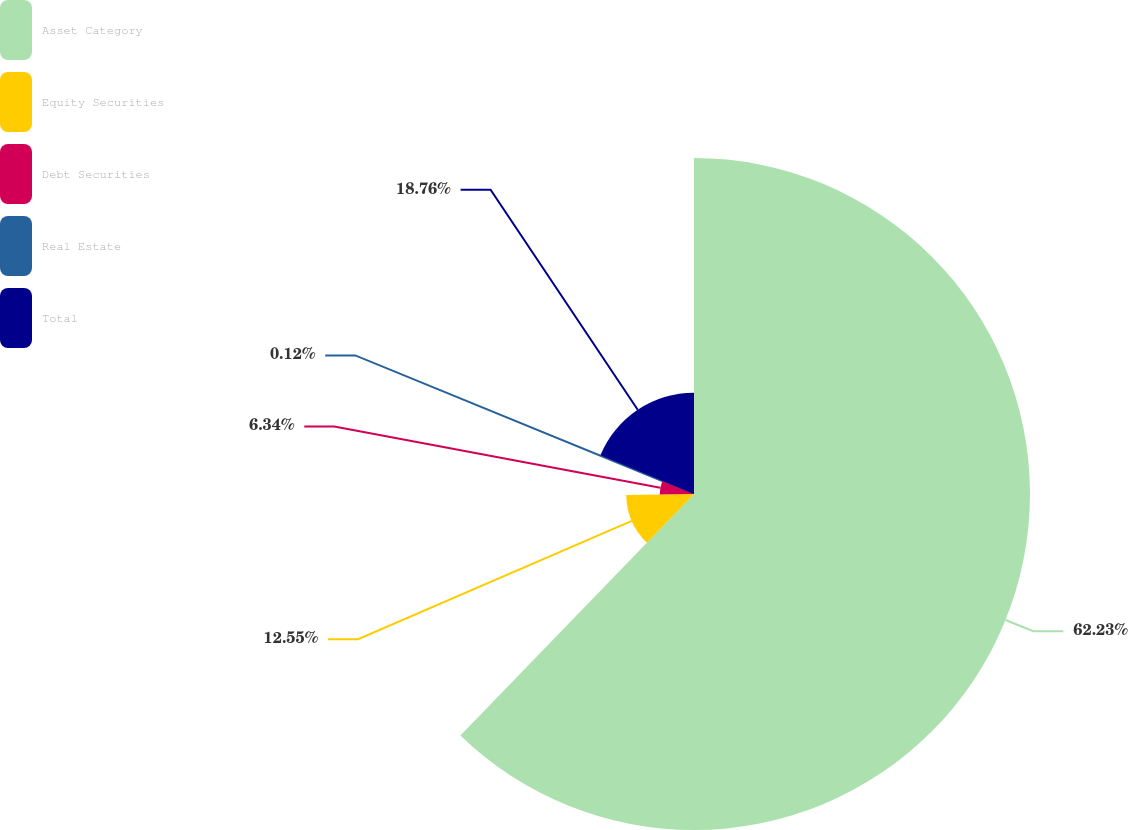Convert chart to OTSL. <chart><loc_0><loc_0><loc_500><loc_500><pie_chart><fcel>Asset Category<fcel>Equity Securities<fcel>Debt Securities<fcel>Real Estate<fcel>Total<nl><fcel>62.24%<fcel>12.55%<fcel>6.34%<fcel>0.12%<fcel>18.76%<nl></chart> 